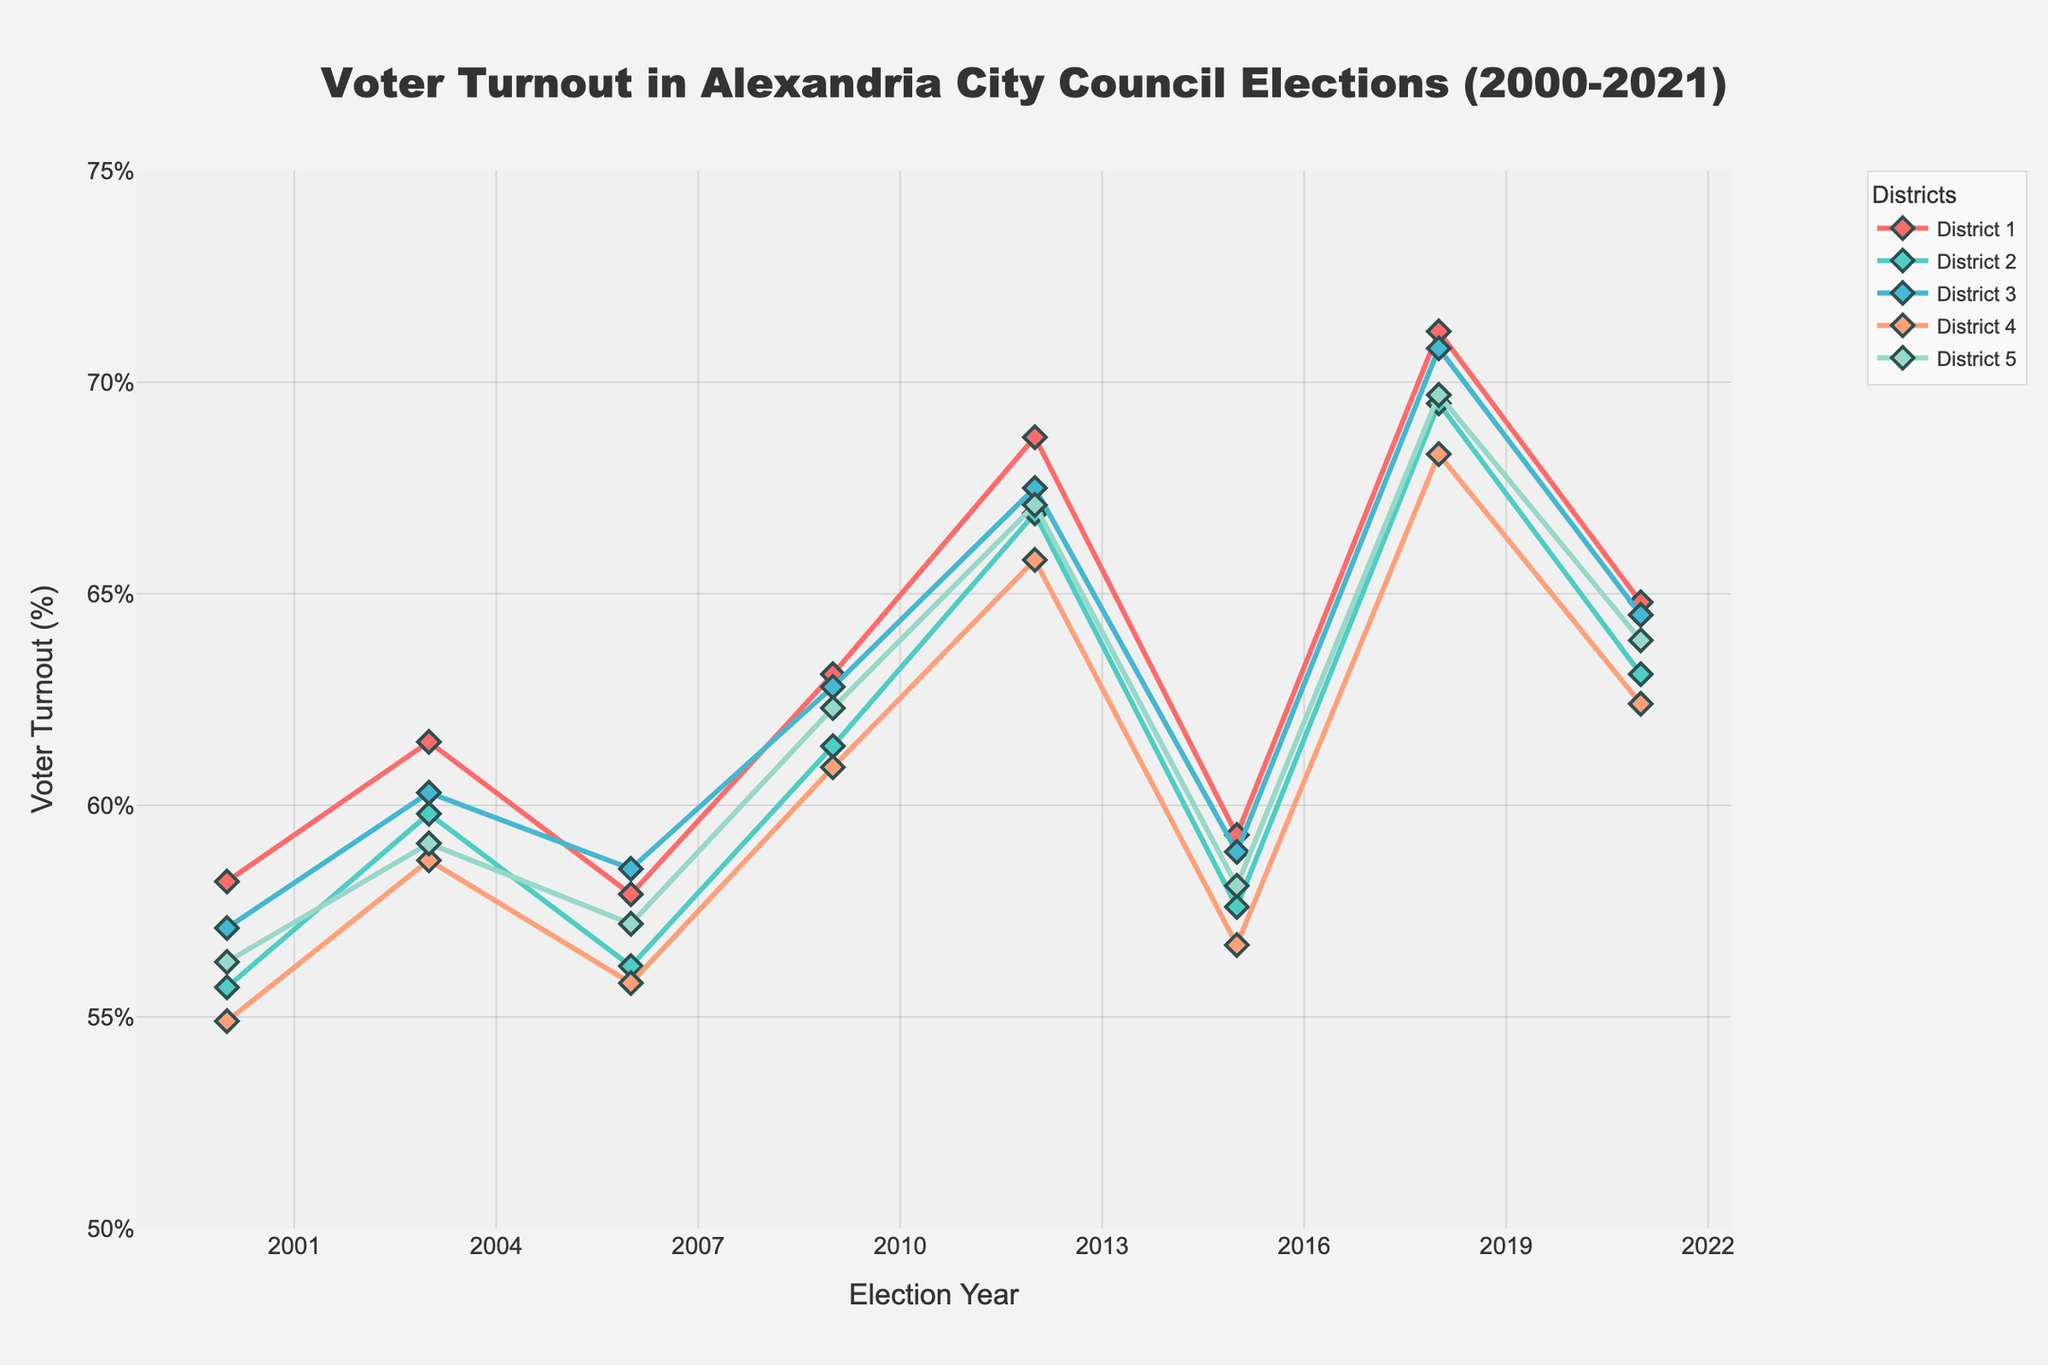What's the overall trend in voter turnout from 2000 to 2021 for District 1? The voter turnout in District 1 increased from 58.2% in 2000 to a peak of 71.2% in 2018, before slightly decreasing to 64.8% in 2021.
Answer: Increased overall Which district had the highest voter turnout in 2009? To find the district with the highest voter turnout in 2009, compare the values of all districts for that year. District 1 had 63.1%, District 2 had 61.4%, District 3 had 62.8%, District 4 had 60.9%, and District 5 had 62.3%. District 1 had the highest turnout.
Answer: District 1 Compare the voter turnout difference between 2012 and 2015 in District 4. The voter turnout in District 4 was 65.8% in 2012 and decreased to 56.7% in 2015. The difference is 65.8% - 56.7% = 9.1%.
Answer: 9.1% Between 2006 and 2009, which district saw the largest increase in voter turnout? The increases are: District 1 (63.1% - 57.9% = 5.2%), District 2 (61.4% - 56.2% = 5.2%), District 3 (62.8% - 58.5% = 4.3%), District 4 (60.9% - 55.8% = 5.1%), District 5 (62.3% - 57.2% = 5.1%). District 1 and District 2 saw the largest increase of 5.2%.
Answer: Districts 1 & 2 In which year did District 3 have voter turnout closest to District 5? To find the year where the closing values were the closest, check each year's data for District 3 and District 5 to find the absolute differences: 2000 (57.1%, 56.3%), 2003 (60.3%, 59.1%), 2006 (58.5%, 57.2%), 2009 (62.8%, 62.3%), 2012 (67.5%, 67.1%), 2015 (58.9%, 58.1%), 2018 (70.8%, 69.7%), 2021 (64.5%, 63.9%). The smallest difference is in 2012 with a difference of 0.4%.
Answer: 2012 What is the average voter turnout percentage for District 2 over the shown years? Calculate the average for District 2: (55.7 + 59.8 + 56.2 + 61.4 + 66.9 + 57.6 + 69.5 + 63.1) / 8 = 61.55%.
Answer: 61.55% In 2018, which two districts had the closest voter turnouts, and what was the difference? In 2018, the voter turnouts were: District 1 (71.2%), District 2 (69.5%), District 3 (70.8%), District 4 (68.3%), District 5 (69.7%). The closest pair is District 3 and District 5 with a difference of 70.8% - 69.7% = 1.1%.
Answer: Districts 3 & 5, 1.1% Which district consistently increased its voter turnout from 2000 to 2018? Check each district's voter trend: 
District 1: 58.2, 61.5, 57.9, 63.1, 68.7, 59.3, 71.2 (Not consistent)
District 2: 55.7, 59.8, 56.2, 61.4, 66.9, 57.6, 69.5 (Not consistent)
District 3: 57.1, 60.3, 58.5, 62.8, 67.5, 58.9, 70.8 (Not consistent)
District 4: 54.9, 58.7, 55.8, 60.9, 65.8, 56.7, 68.3 (Not consistent)
District 5: 56.3, 59.1, 57.2, 62.3, 67.1, 58.1, 69.7 (Not consistent)
No district consistently increased over the period.
Answer: None 